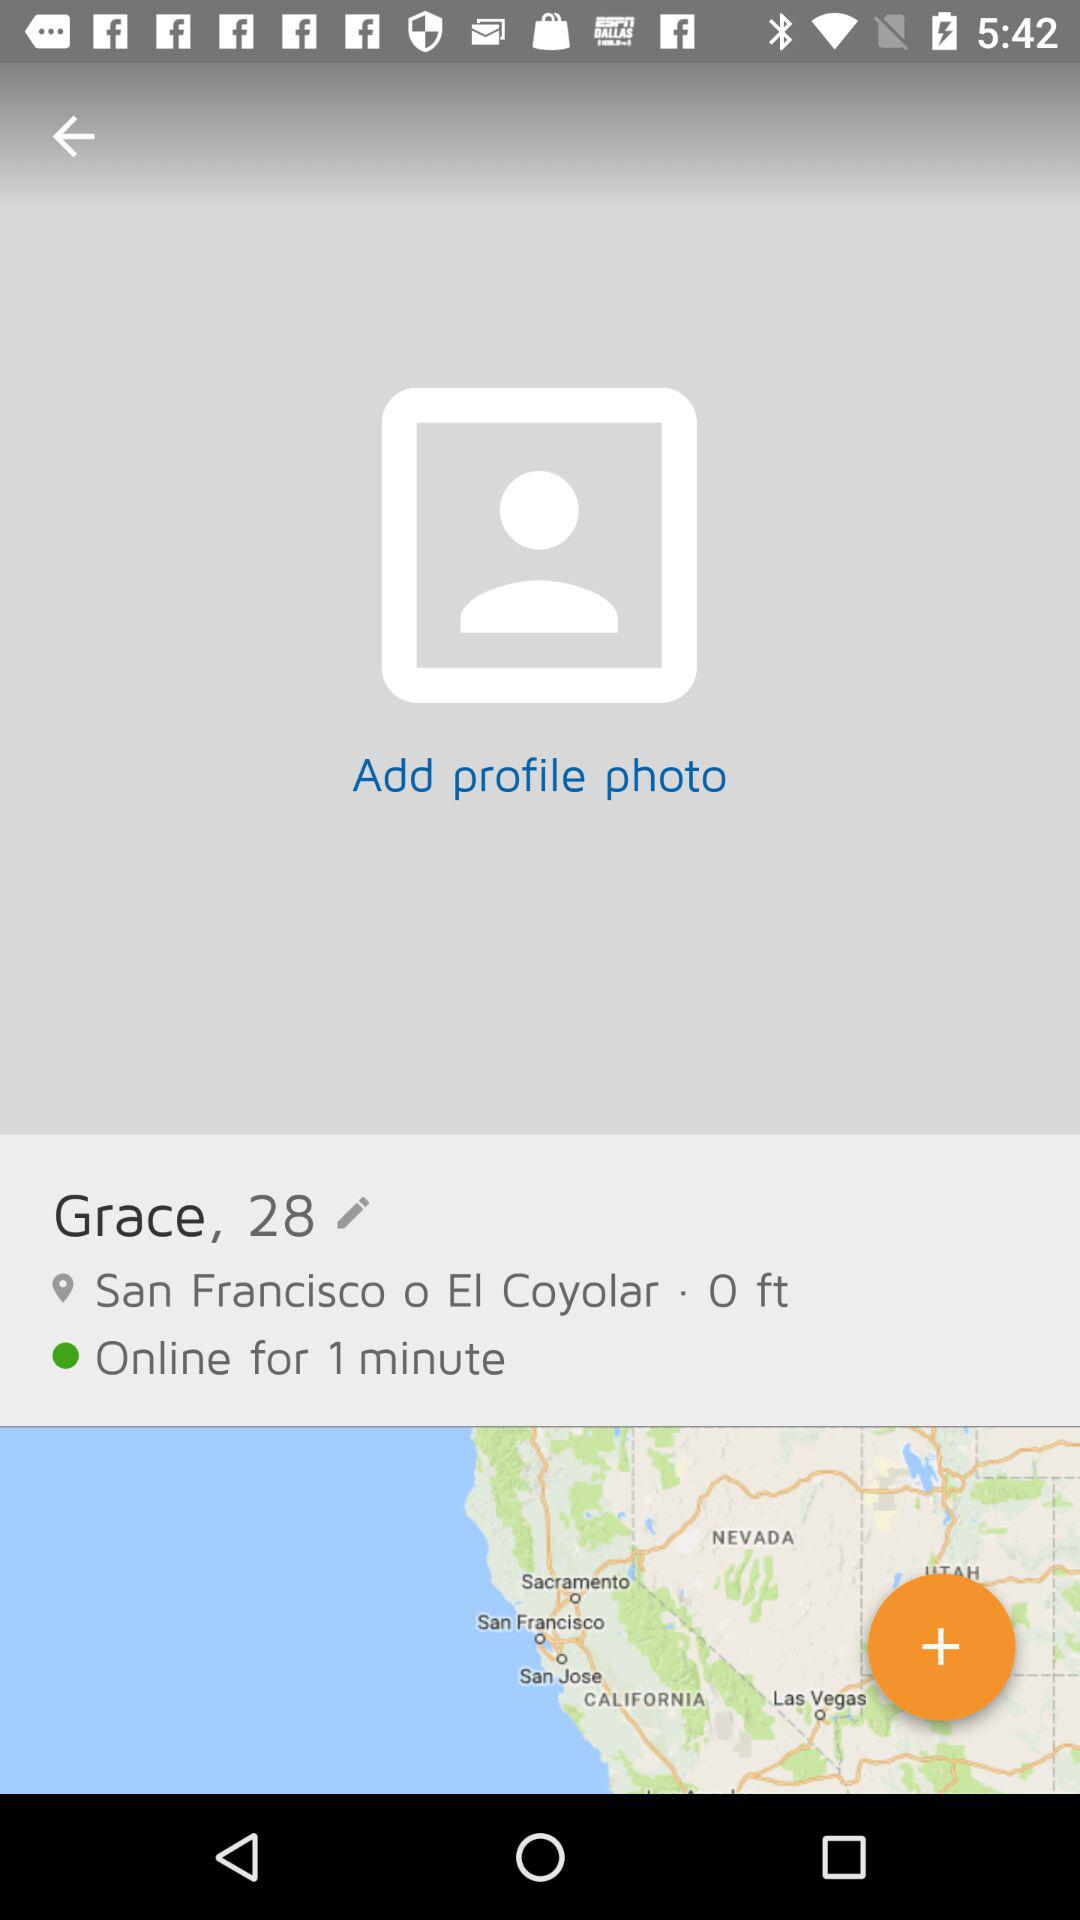What is the location? The location is San Francisco o El Coyolar. 